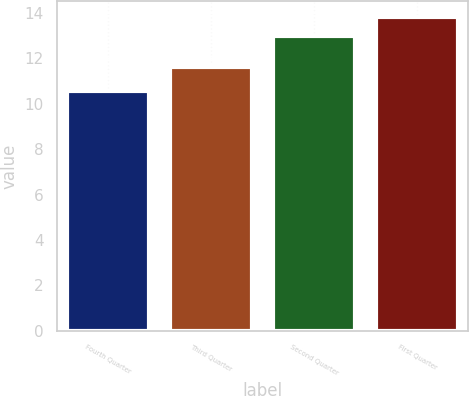<chart> <loc_0><loc_0><loc_500><loc_500><bar_chart><fcel>Fourth Quarter<fcel>Third Quarter<fcel>Second Quarter<fcel>First Quarter<nl><fcel>10.55<fcel>11.61<fcel>12.97<fcel>13.81<nl></chart> 